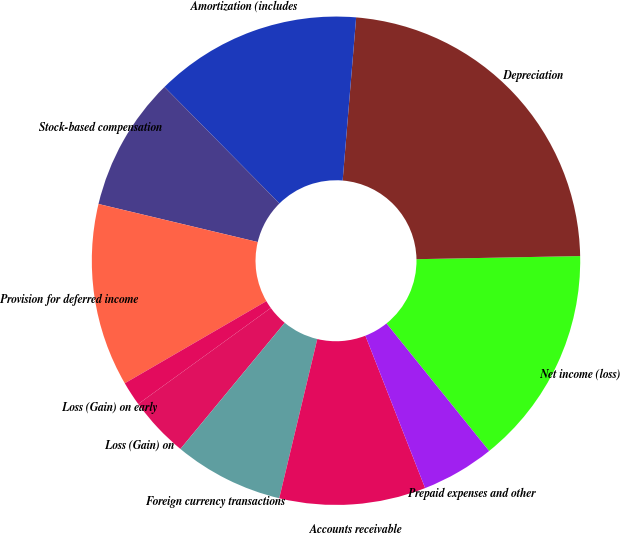Convert chart. <chart><loc_0><loc_0><loc_500><loc_500><pie_chart><fcel>Net income (loss)<fcel>Depreciation<fcel>Amortization (includes<fcel>Stock-based compensation<fcel>Provision for deferred income<fcel>Loss (Gain) on early<fcel>Loss (Gain) on<fcel>Foreign currency transactions<fcel>Accounts receivable<fcel>Prepaid expenses and other<nl><fcel>14.52%<fcel>23.38%<fcel>13.71%<fcel>8.87%<fcel>12.1%<fcel>1.61%<fcel>4.03%<fcel>7.26%<fcel>9.68%<fcel>4.84%<nl></chart> 